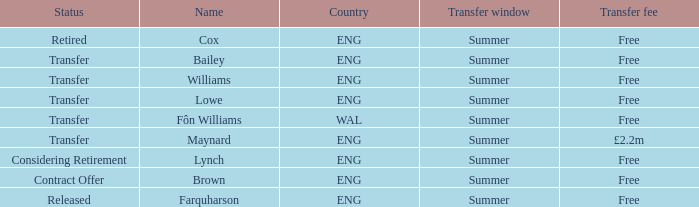What is Brown's transfer window? Summer. 